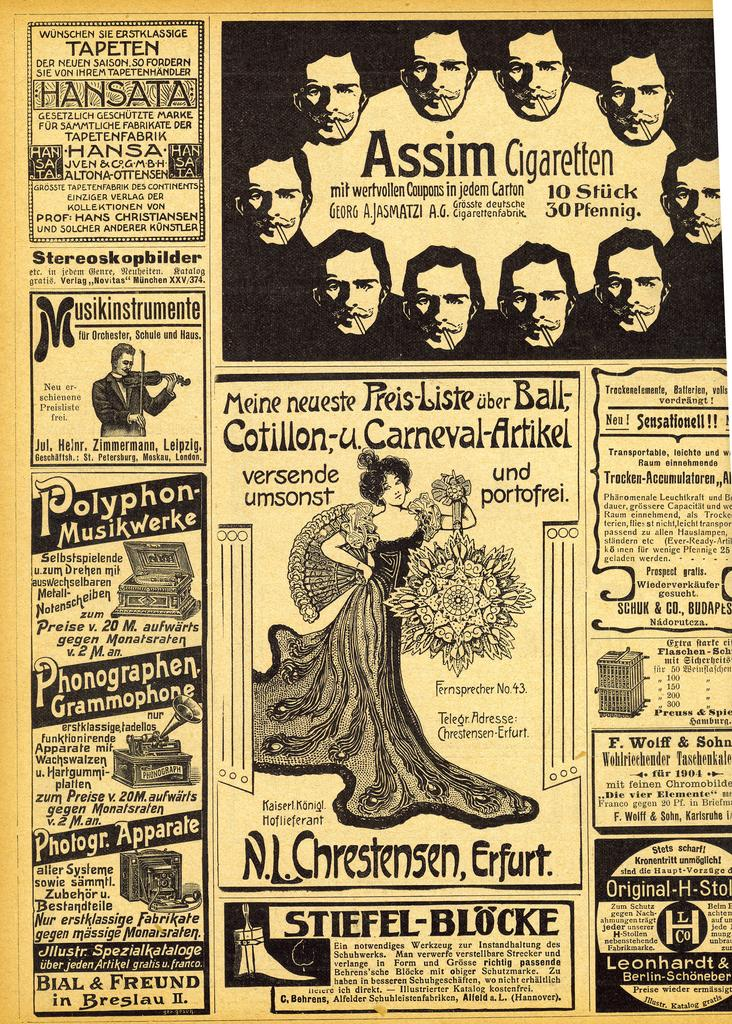Provide a one-sentence caption for the provided image. A page out of an old newspaper showing many advertisements, including on for Phonographen Grammophone. 